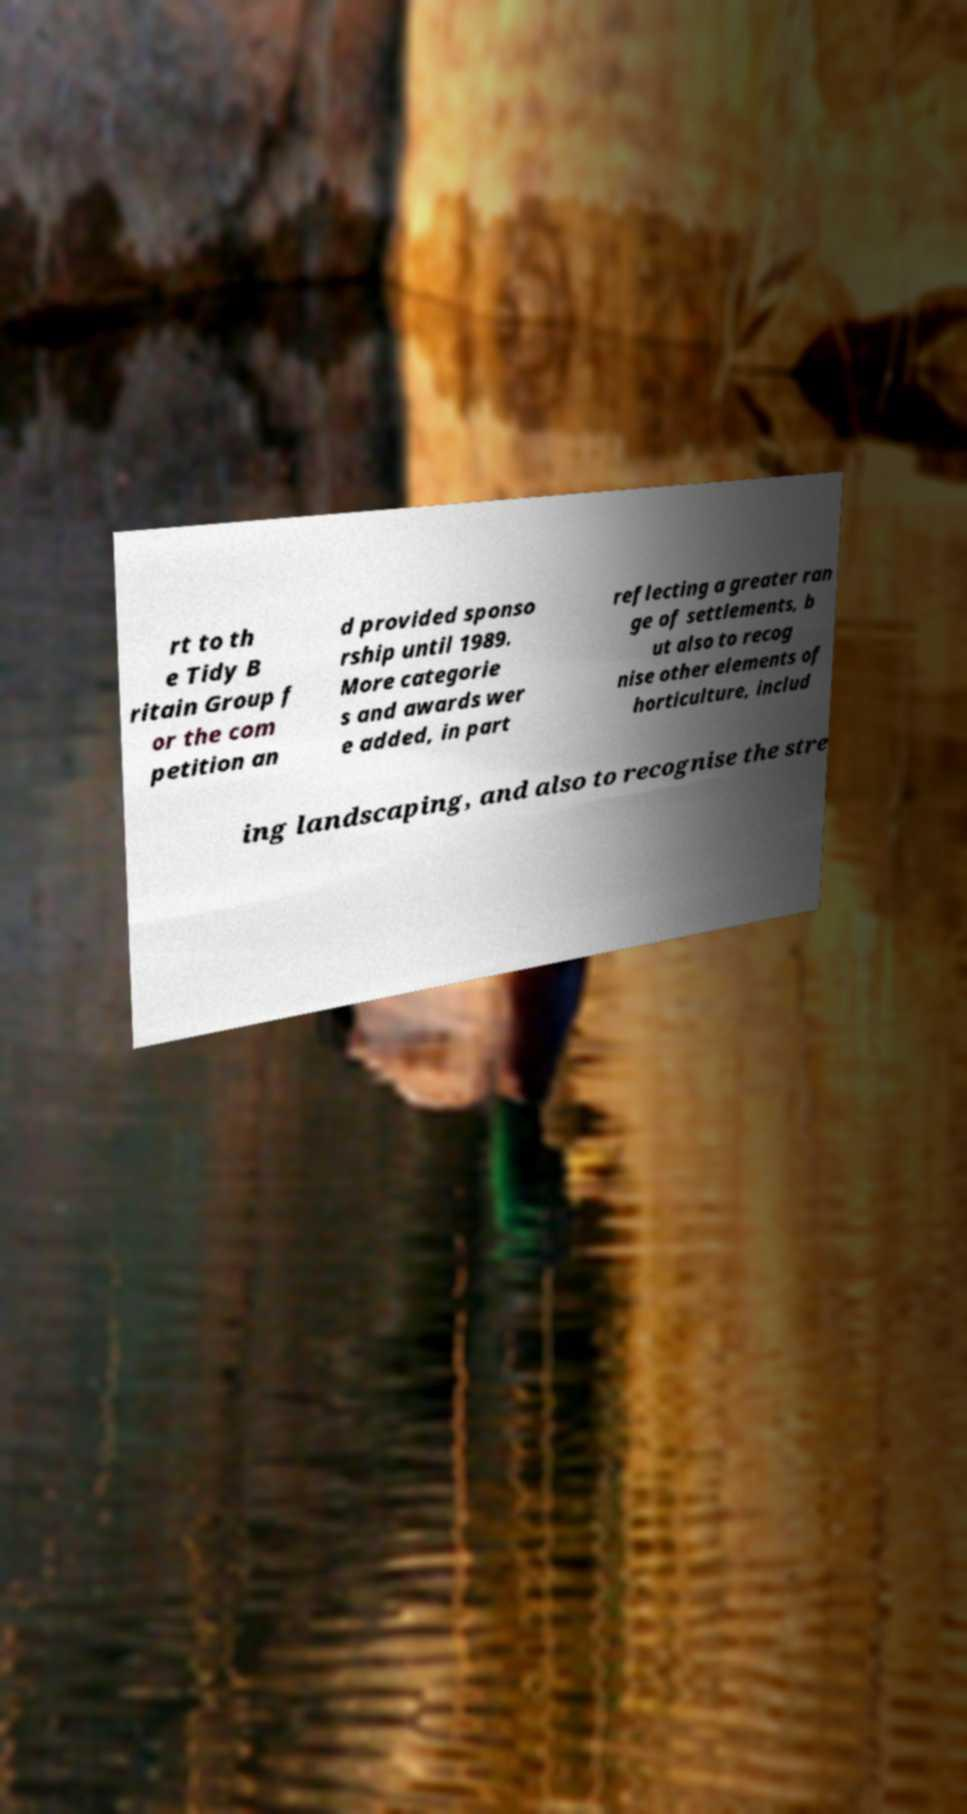There's text embedded in this image that I need extracted. Can you transcribe it verbatim? rt to th e Tidy B ritain Group f or the com petition an d provided sponso rship until 1989. More categorie s and awards wer e added, in part reflecting a greater ran ge of settlements, b ut also to recog nise other elements of horticulture, includ ing landscaping, and also to recognise the stre 